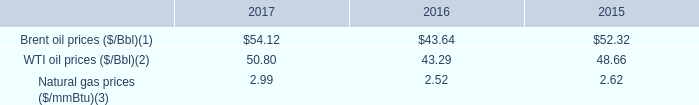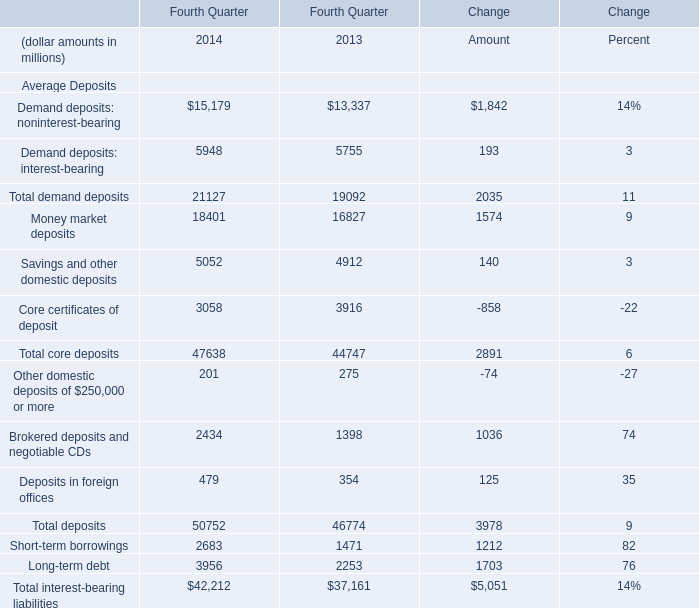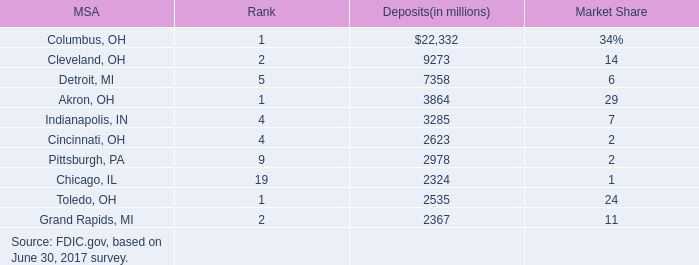what are the natural gas prices as a percentage of wti oil prices in 2016? 
Computations: (2.52 / 43.29)
Answer: 0.05821. 